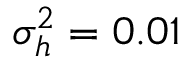Convert formula to latex. <formula><loc_0><loc_0><loc_500><loc_500>\sigma _ { h } ^ { 2 } = 0 . 0 1</formula> 